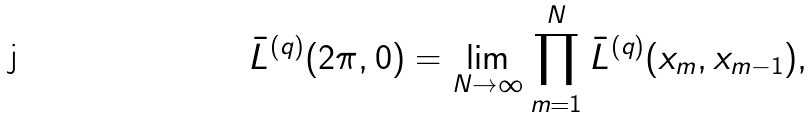Convert formula to latex. <formula><loc_0><loc_0><loc_500><loc_500>\bar { L } ^ { ( q ) } ( 2 \pi , 0 ) = \lim _ { N \to \infty } \prod _ { m = 1 } ^ { N } \bar { L } ^ { ( q ) } ( x _ { m } , x _ { m - 1 } ) ,</formula> 